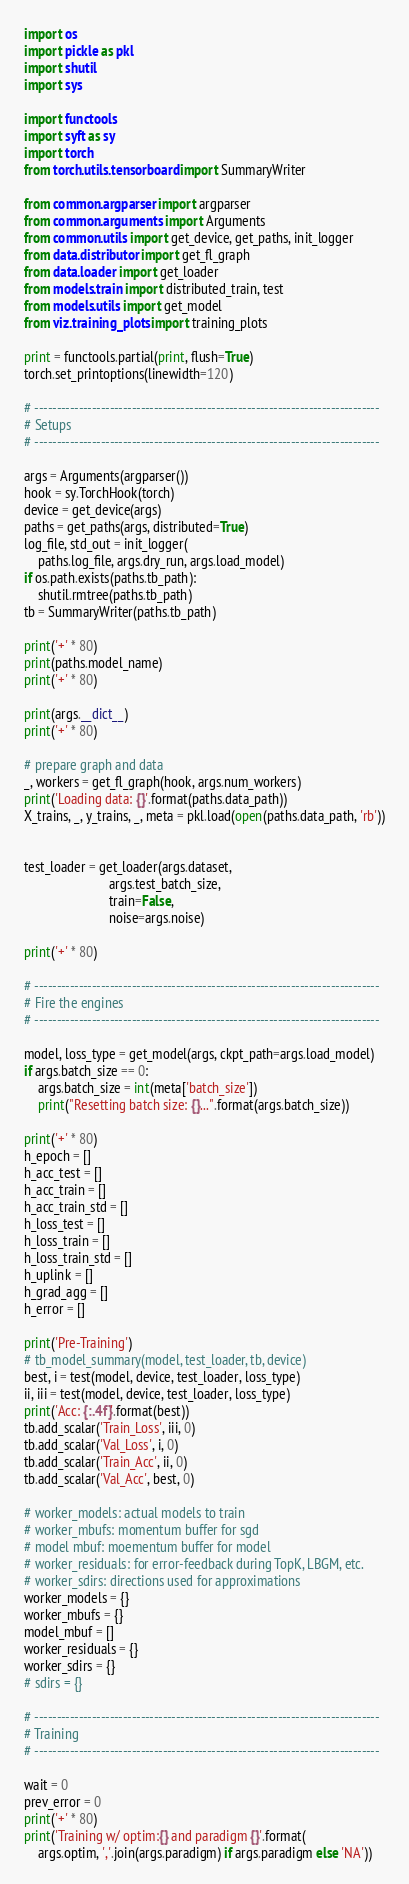Convert code to text. <code><loc_0><loc_0><loc_500><loc_500><_Python_>import os
import pickle as pkl
import shutil
import sys

import functools
import syft as sy
import torch
from torch.utils.tensorboard import SummaryWriter

from common.argparser import argparser
from common.arguments import Arguments
from common.utils import get_device, get_paths, init_logger
from data.distributor import get_fl_graph
from data.loader import get_loader
from models.train import distributed_train, test
from models.utils import get_model
from viz.training_plots import training_plots

print = functools.partial(print, flush=True)
torch.set_printoptions(linewidth=120)

# ------------------------------------------------------------------------------
# Setups
# ------------------------------------------------------------------------------

args = Arguments(argparser())
hook = sy.TorchHook(torch)
device = get_device(args)
paths = get_paths(args, distributed=True)
log_file, std_out = init_logger(
    paths.log_file, args.dry_run, args.load_model)
if os.path.exists(paths.tb_path):
    shutil.rmtree(paths.tb_path)
tb = SummaryWriter(paths.tb_path)

print('+' * 80)
print(paths.model_name)
print('+' * 80)

print(args.__dict__)
print('+' * 80)

# prepare graph and data
_, workers = get_fl_graph(hook, args.num_workers)
print('Loading data: {}'.format(paths.data_path))
X_trains, _, y_trains, _, meta = pkl.load(open(paths.data_path, 'rb'))


test_loader = get_loader(args.dataset,
                         args.test_batch_size,
                         train=False,
                         noise=args.noise)

print('+' * 80)

# ------------------------------------------------------------------------------
# Fire the engines
# ------------------------------------------------------------------------------

model, loss_type = get_model(args, ckpt_path=args.load_model)
if args.batch_size == 0:
    args.batch_size = int(meta['batch_size'])
    print("Resetting batch size: {}...".format(args.batch_size))

print('+' * 80)
h_epoch = []
h_acc_test = []
h_acc_train = []
h_acc_train_std = []
h_loss_test = []
h_loss_train = []
h_loss_train_std = []
h_uplink = []
h_grad_agg = []
h_error = []

print('Pre-Training')
# tb_model_summary(model, test_loader, tb, device)
best, i = test(model, device, test_loader, loss_type)
ii, iii = test(model, device, test_loader, loss_type)
print('Acc: {:.4f}'.format(best))
tb.add_scalar('Train_Loss', iii, 0)
tb.add_scalar('Val_Loss', i, 0)
tb.add_scalar('Train_Acc', ii, 0)
tb.add_scalar('Val_Acc', best, 0)

# worker_models: actual models to train
# worker_mbufs: momentum buffer for sgd
# model mbuf: moementum buffer for model
# worker_residuals: for error-feedback during TopK, LBGM, etc.
# worker_sdirs: directions used for approximations
worker_models = {}
worker_mbufs = {}
model_mbuf = []
worker_residuals = {}
worker_sdirs = {}
# sdirs = {}

# ------------------------------------------------------------------------------
# Training
# ------------------------------------------------------------------------------

wait = 0
prev_error = 0
print('+' * 80)
print('Training w/ optim:{} and paradigm {}'.format(
    args.optim, ','.join(args.paradigm) if args.paradigm else 'NA'))</code> 